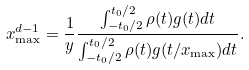Convert formula to latex. <formula><loc_0><loc_0><loc_500><loc_500>x _ { \max } ^ { d - 1 } = \frac { 1 } { y } \frac { \int _ { - t _ { 0 } / 2 } ^ { t _ { 0 } / 2 } \rho ( t ) g ( t ) d t } { \int _ { - t _ { 0 } / 2 } ^ { t _ { 0 } / 2 } \rho ( t ) g ( t / x _ { \max } ) d t } .</formula> 